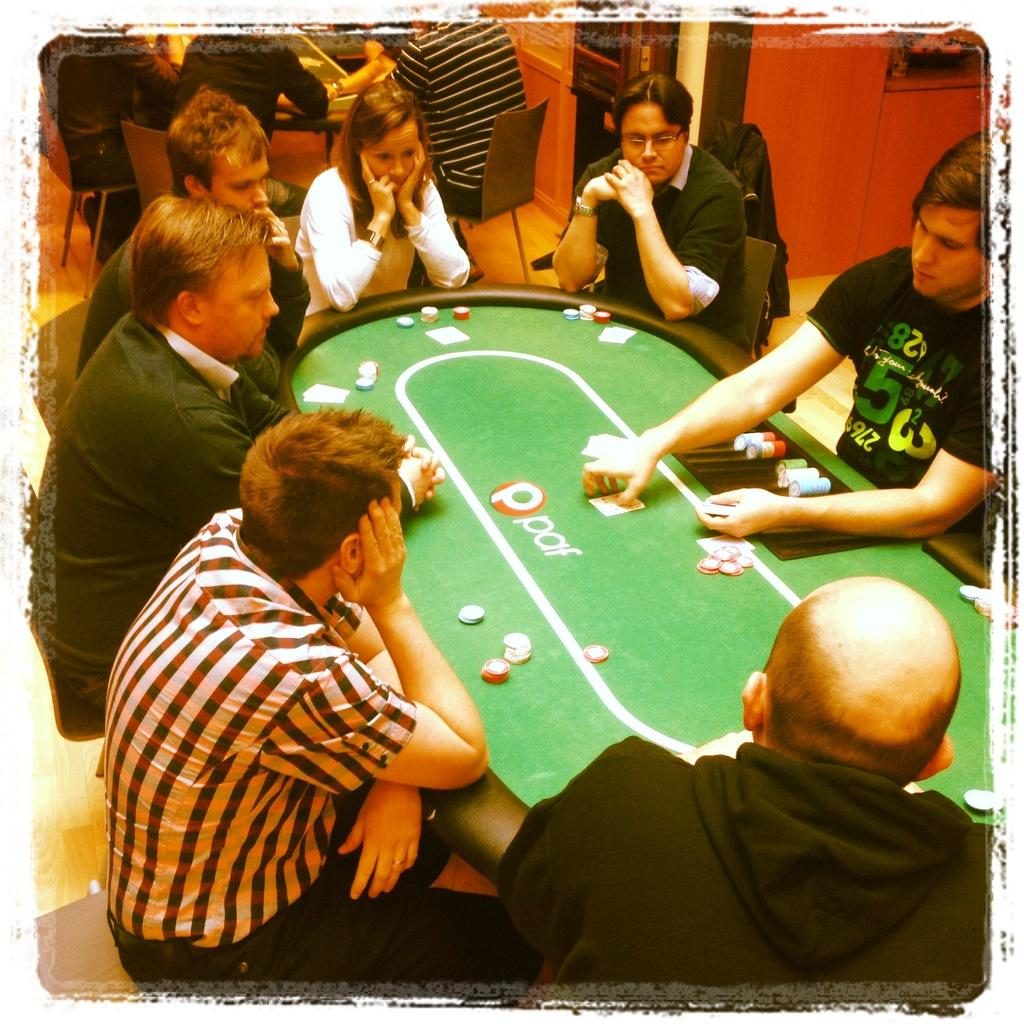What are the people in the image doing? The people in the image are sitting. What object can be seen in the image that is typically used for eating or working on? There is a table in the image. What type of driving is happening in the image? There is no driving present in the image; it features people sitting at a table. What kind of beam can be seen supporting the table in the image? There is no beam visible in the image; it only shows people sitting at a table. 